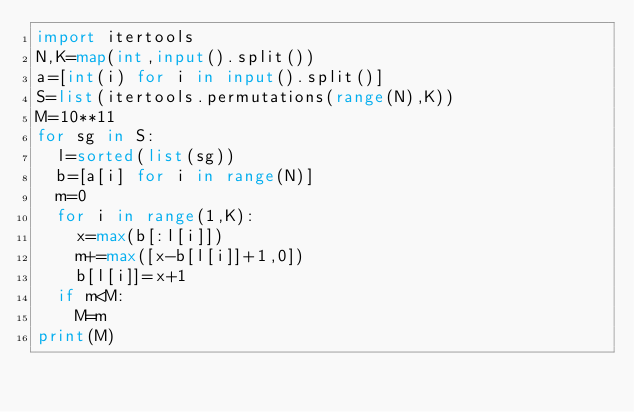<code> <loc_0><loc_0><loc_500><loc_500><_Python_>import itertools
N,K=map(int,input().split())
a=[int(i) for i in input().split()]
S=list(itertools.permutations(range(N),K))
M=10**11
for sg in S:
  l=sorted(list(sg))
  b=[a[i] for i in range(N)]
  m=0
  for i in range(1,K):
    x=max(b[:l[i]])
    m+=max([x-b[l[i]]+1,0])
    b[l[i]]=x+1
  if m<M:
    M=m
print(M)
</code> 